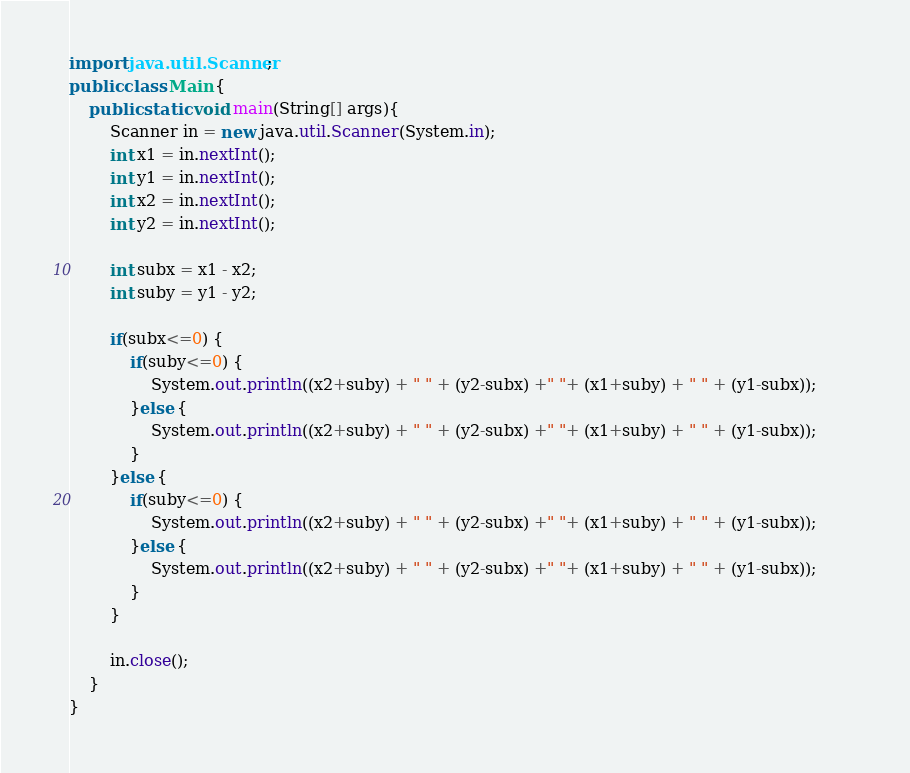<code> <loc_0><loc_0><loc_500><loc_500><_Java_>import java.util.Scanner;
public class Main {
	public static void main(String[] args){
		Scanner in = new java.util.Scanner(System.in);
		int x1 = in.nextInt();
		int y1 = in.nextInt();
		int x2 = in.nextInt();
		int y2 = in.nextInt();
		
		int subx = x1 - x2;
		int suby = y1 - y2;
		
		if(subx<=0) {
			if(suby<=0) {
				System.out.println((x2+suby) + " " + (y2-subx) +" "+ (x1+suby) + " " + (y1-subx));		
			}else {
				System.out.println((x2+suby) + " " + (y2-subx) +" "+ (x1+suby) + " " + (y1-subx));
			}
		}else {
			if(suby<=0) {
				System.out.println((x2+suby) + " " + (y2-subx) +" "+ (x1+suby) + " " + (y1-subx));		
			}else {
				System.out.println((x2+suby) + " " + (y2-subx) +" "+ (x1+suby) + " " + (y1-subx));
			}
		}
	
		in.close();
	}
}
</code> 